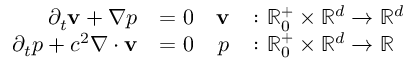<formula> <loc_0><loc_0><loc_500><loc_500>\begin{array} { r l r l } { \partial _ { t } \mathbf v + \nabla p } & { = 0 } & { \mathbf v } & { \colon \mathbb { R } _ { 0 } ^ { + } \times \mathbb { R } ^ { d } \to \mathbb { R } ^ { d } } \\ { \partial _ { t } p + c ^ { 2 } \nabla \cdot \mathbf v } & { = 0 } & { p } & { \colon \mathbb { R } _ { 0 } ^ { + } \times \mathbb { R } ^ { d } \to \mathbb { R } } \end{array}</formula> 